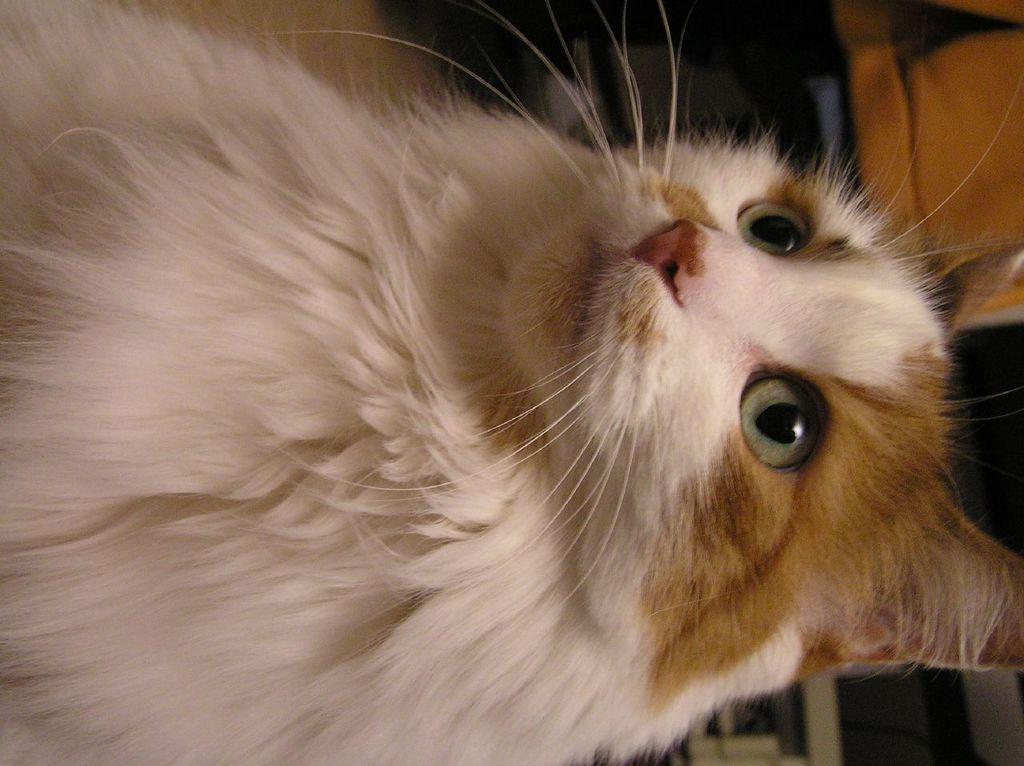What type of animal is in the foreground of the image? There is a white cat in the foreground of the image. What can be seen in the background of the image? There are objects visible in the background of the image. What type of flooring is at the bottom of the image? There is a wooden floor at the bottom of the image. What type of stamp can be seen on the cat's head in the image? There is no stamp on the cat's head in the image, and the cat does not have a head in the image. What kind of cake is being served in the image? There is no cake present in the image. 